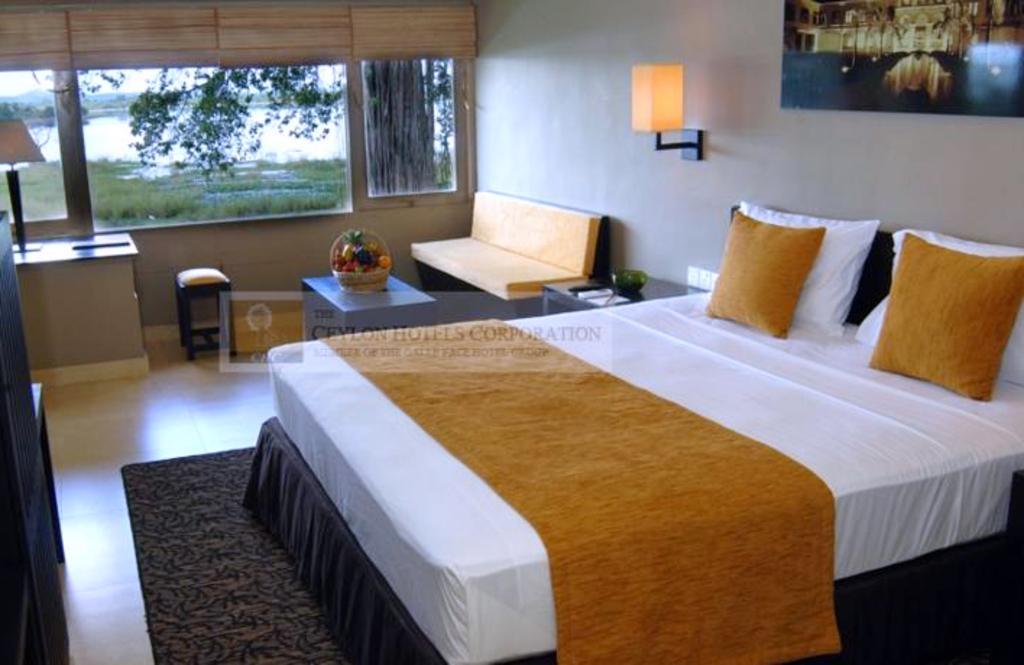Could you give a brief overview of what you see in this image? In this picture i could see a white colored bed and the yellow pillows in the background back of a wall frame hanging on the wall and a lamp attached to the wall, beside there is a table bedside table and beside side table there is a yellow color sofa in front of yellow color sofa there is a center piece table on the center piece table there is a is fruit basket and beside that there is small stool and in the left corner there is a table and on that table there is book and lamp and to the left corner there is a wooden cabinet. In the middle of the picture there is a open glass window i could see trees grass and water. 